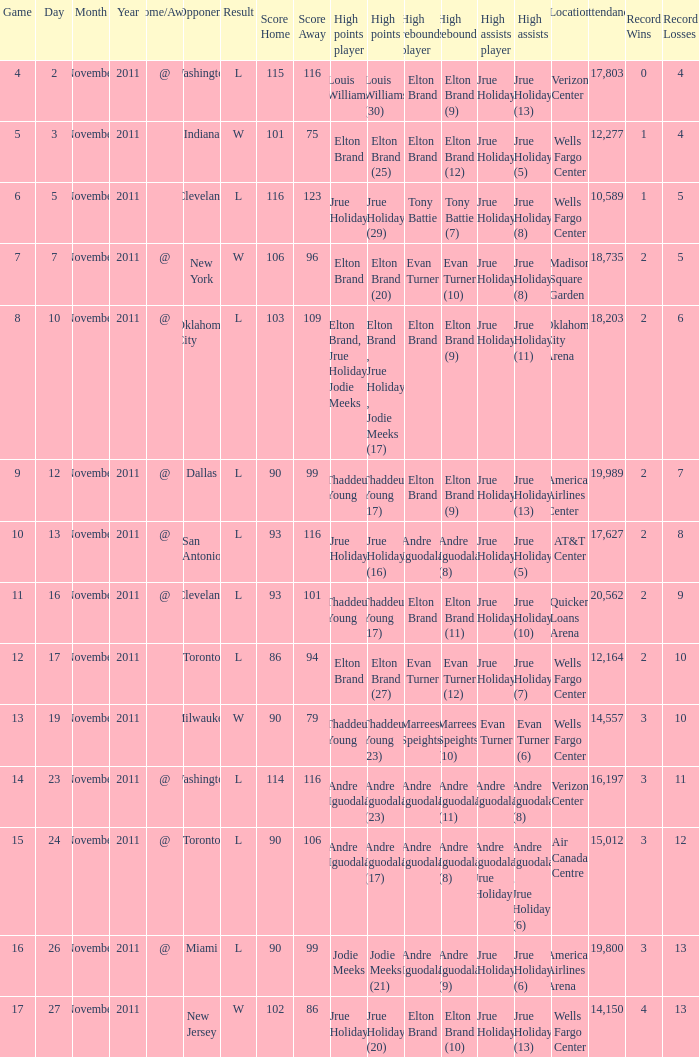What is the game number for the game with a score of l 90–106 (ot)? 15.0. 